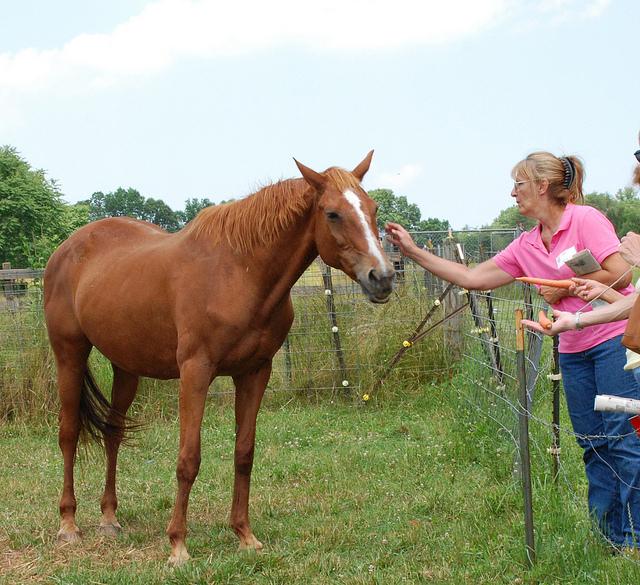What color is the horse's mane?
Write a very short answer. Brown. How many horses?
Answer briefly. 1. What color shirt is the woman wearing?
Concise answer only. Pink. Are the horses out to pasture?
Give a very brief answer. Yes. How many horses are in this photo?
Keep it brief. 1. What animal is the old woman petting?
Be succinct. Horse. How many horses in the fence?
Short answer required. 1. How many horses are in the photo?
Answer briefly. 1. What is the fence made of?
Keep it brief. Wire. 